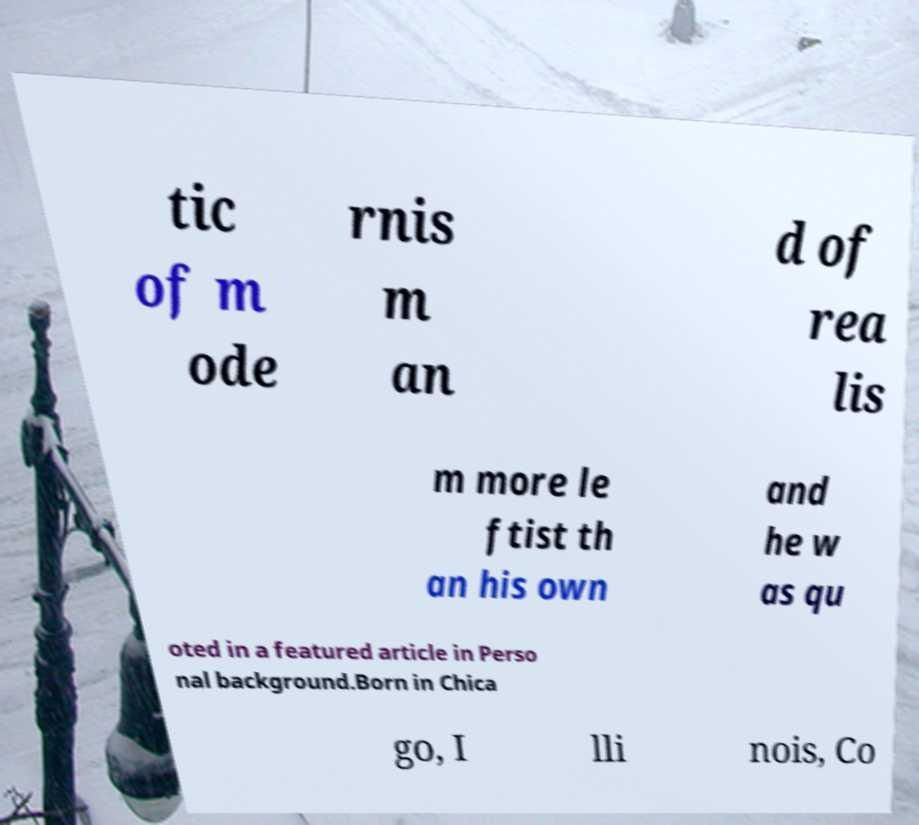Please read and relay the text visible in this image. What does it say? tic of m ode rnis m an d of rea lis m more le ftist th an his own and he w as qu oted in a featured article in Perso nal background.Born in Chica go, I lli nois, Co 